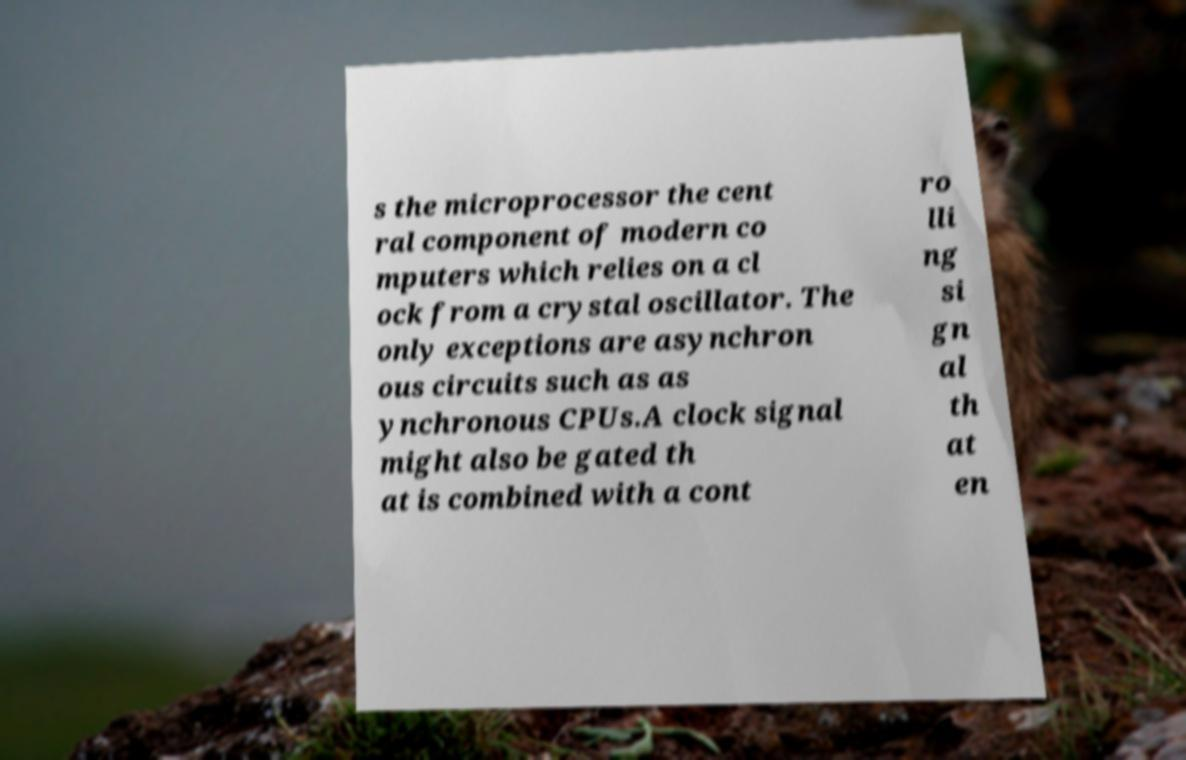For documentation purposes, I need the text within this image transcribed. Could you provide that? s the microprocessor the cent ral component of modern co mputers which relies on a cl ock from a crystal oscillator. The only exceptions are asynchron ous circuits such as as ynchronous CPUs.A clock signal might also be gated th at is combined with a cont ro lli ng si gn al th at en 